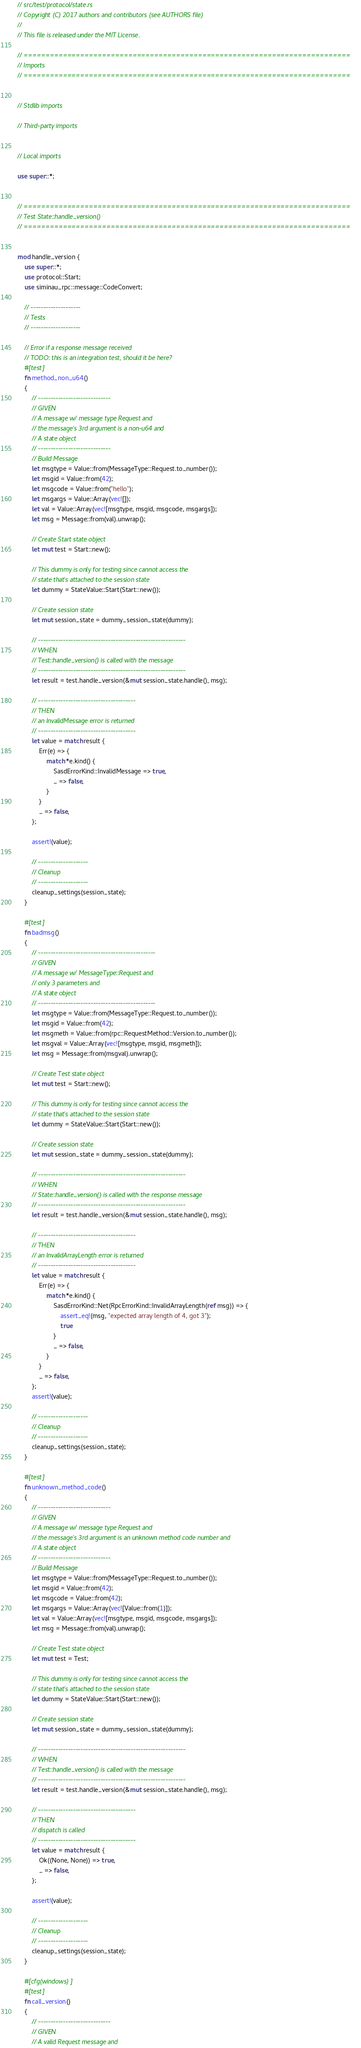<code> <loc_0><loc_0><loc_500><loc_500><_Rust_>// src/test/protocol/state.rs
// Copyright (C) 2017 authors and contributors (see AUTHORS file)
//
// This file is released under the MIT License.

// ===========================================================================
// Imports
// ===========================================================================


// Stdlib imports

// Third-party imports


// Local imports

use super::*;


// ===========================================================================
// Test State::handle_version()
// ===========================================================================


mod handle_version {
    use super::*;
    use protocol::Start;
    use siminau_rpc::message::CodeConvert;

    // --------------------
    // Tests
    // --------------------

    // Error if a response message received
    // TODO: this is an integration test, should it be here?
    #[test]
    fn method_non_u64()
    {
        // -----------------------------
        // GIVEN
        // A message w/ message type Request and
        // the message's 3rd argument is a non-u64 and
        // A state object
        // -----------------------------
        // Build Message
        let msgtype = Value::from(MessageType::Request.to_number());
        let msgid = Value::from(42);
        let msgcode = Value::from("hello");
        let msgargs = Value::Array(vec![]);
        let val = Value::Array(vec![msgtype, msgid, msgcode, msgargs]);
        let msg = Message::from(val).unwrap();

        // Create Start state object
        let mut test = Start::new();

        // This dummy is only for testing since cannot access the
        // state that's attached to the session state
        let dummy = StateValue::Start(Start::new());

        // Create session state
        let mut session_state = dummy_session_state(dummy);

        // -----------------------------------------------------------
        // WHEN
        // Test::handle_version() is called with the message
        // -----------------------------------------------------------
        let result = test.handle_version(&mut session_state.handle(), msg);

        // ---------------------------------------
        // THEN
        // an InvalidMessage error is returned
        // ---------------------------------------
        let value = match result {
            Err(e) => {
                match *e.kind() {
                    SasdErrorKind::InvalidMessage => true,
                    _ => false,
                }
            }
            _ => false,
        };

        assert!(value);

        // --------------------
        // Cleanup
        // --------------------
        cleanup_settings(session_state);
    }

    #[test]
    fn badmsg()
    {
        // -----------------------------------------------
        // GIVEN
        // A message w/ MessageType::Request and
        // only 3 parameters and
        // A state object
        // -----------------------------------------------
        let msgtype = Value::from(MessageType::Request.to_number());
        let msgid = Value::from(42);
        let msgmeth = Value::from(rpc::RequestMethod::Version.to_number());
        let msgval = Value::Array(vec![msgtype, msgid, msgmeth]);
        let msg = Message::from(msgval).unwrap();

        // Create Test state object
        let mut test = Start::new();

        // This dummy is only for testing since cannot access the
        // state that's attached to the session state
        let dummy = StateValue::Start(Start::new());

        // Create session state
        let mut session_state = dummy_session_state(dummy);

        // -----------------------------------------------------------
        // WHEN
        // State::handle_version() is called with the response message
        // -----------------------------------------------------------
        let result = test.handle_version(&mut session_state.handle(), msg);

        // ---------------------------------------
        // THEN
        // an InvalidArrayLength error is returned
        // ---------------------------------------
        let value = match result {
            Err(e) => {
                match *e.kind() {
                    SasdErrorKind::Net(RpcErrorKind::InvalidArrayLength(ref msg)) => {
                        assert_eq!(msg, "expected array length of 4, got 3");
                        true
                    }
                    _ => false,
                }
            }
            _ => false,
        };
        assert!(value);

        // --------------------
        // Cleanup
        // --------------------
        cleanup_settings(session_state);
    }

    #[test]
    fn unknown_method_code()
    {
        // -----------------------------
        // GIVEN
        // A message w/ message type Request and
        // the message's 3rd argument is an unknown method code number and
        // A state object
        // -----------------------------
        // Build Message
        let msgtype = Value::from(MessageType::Request.to_number());
        let msgid = Value::from(42);
        let msgcode = Value::from(42);
        let msgargs = Value::Array(vec![Value::from(1)]);
        let val = Value::Array(vec![msgtype, msgid, msgcode, msgargs]);
        let msg = Message::from(val).unwrap();

        // Create Test state object
        let mut test = Test;

        // This dummy is only for testing since cannot access the
        // state that's attached to the session state
        let dummy = StateValue::Start(Start::new());

        // Create session state
        let mut session_state = dummy_session_state(dummy);

        // -----------------------------------------------------------
        // WHEN
        // Test::handle_version() is called with the message
        // -----------------------------------------------------------
        let result = test.handle_version(&mut session_state.handle(), msg);

        // ---------------------------------------
        // THEN
        // dispatch is called
        // ---------------------------------------
        let value = match result {
            Ok((None, None)) => true,
            _ => false,
        };

        assert!(value);

        // --------------------
        // Cleanup
        // --------------------
        cleanup_settings(session_state);
    }

    #[cfg(windows)]
    #[test]
    fn call_version()
    {
        // -----------------------------
        // GIVEN
        // A valid Request message and</code> 